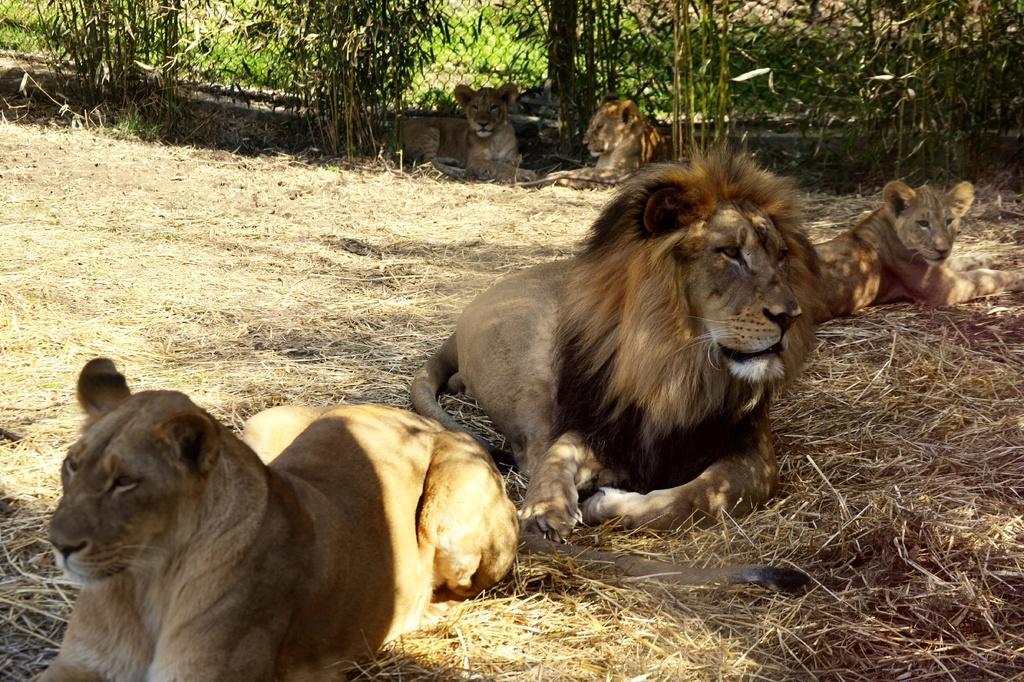Describe this image in one or two sentences. In the center of the image we can see lions. In the background there is a fence, trees and grass. 